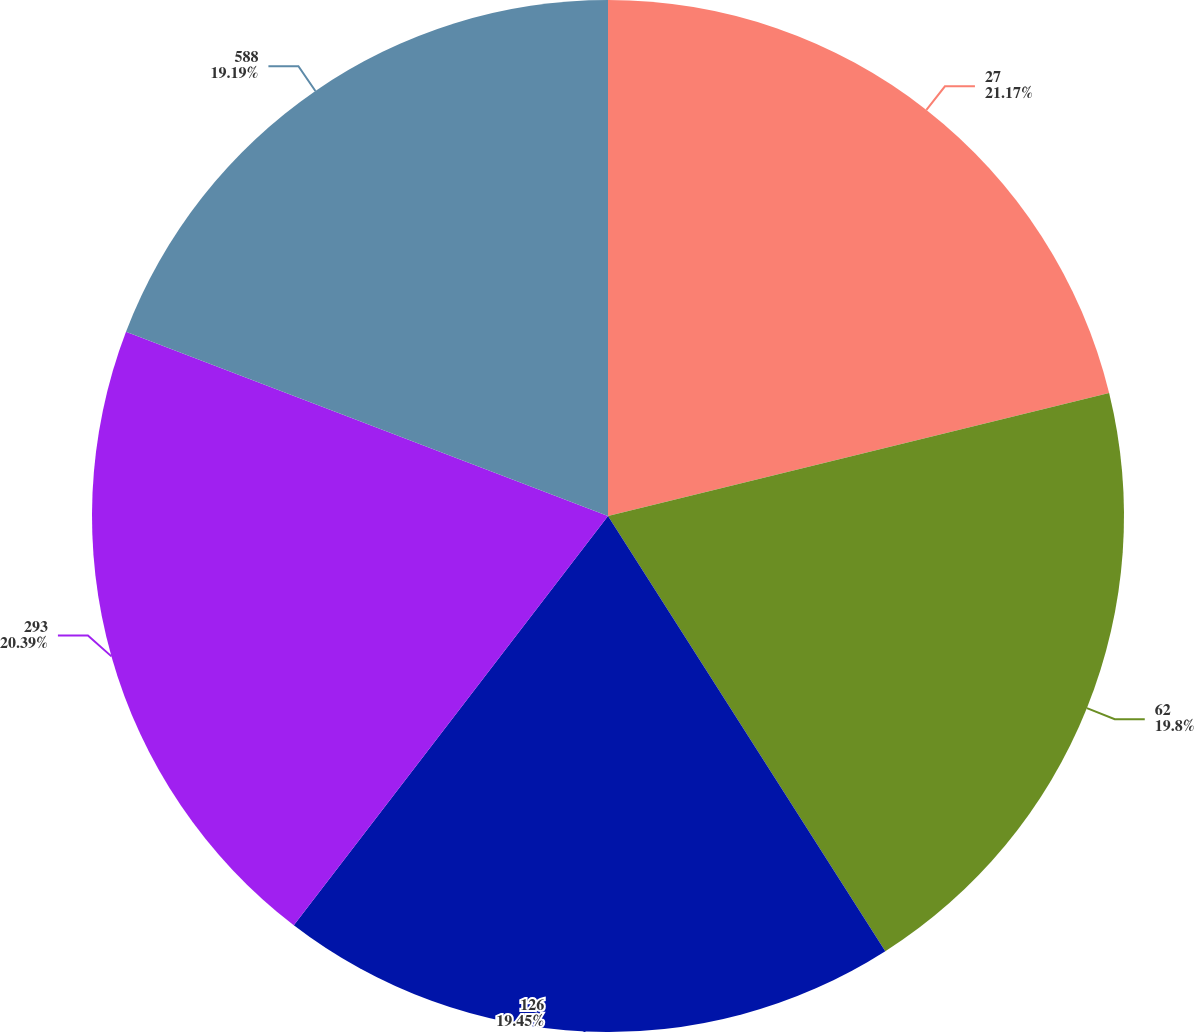<chart> <loc_0><loc_0><loc_500><loc_500><pie_chart><fcel>27<fcel>62<fcel>126<fcel>293<fcel>588<nl><fcel>21.17%<fcel>19.8%<fcel>19.45%<fcel>20.39%<fcel>19.19%<nl></chart> 